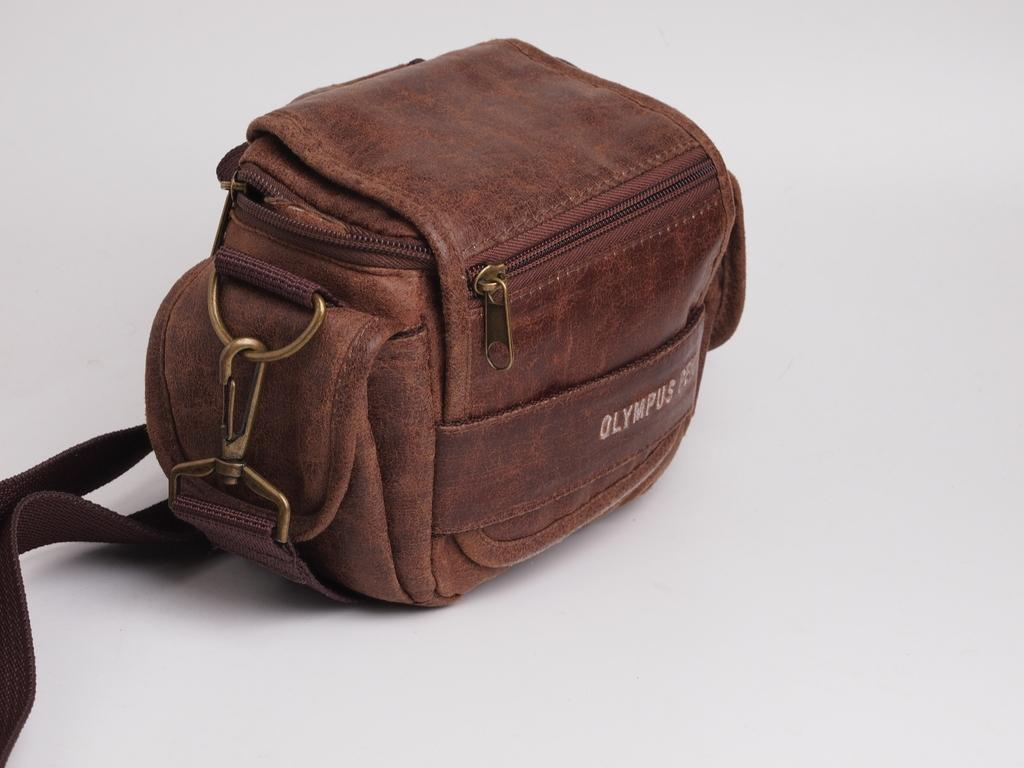What object is present in the image? There is a bag in the image. What feature does the bag have? The bag has straps. On what surface is the bag placed? The bag is on a white color platform. How does the bag express regret in the image? The bag does not express regret in the image, as it is an inanimate object and cannot have emotions or express them. 